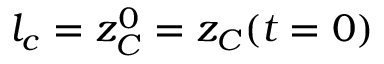<formula> <loc_0><loc_0><loc_500><loc_500>l _ { c } = z _ { C } ^ { 0 } = z _ { C } ( t = 0 )</formula> 